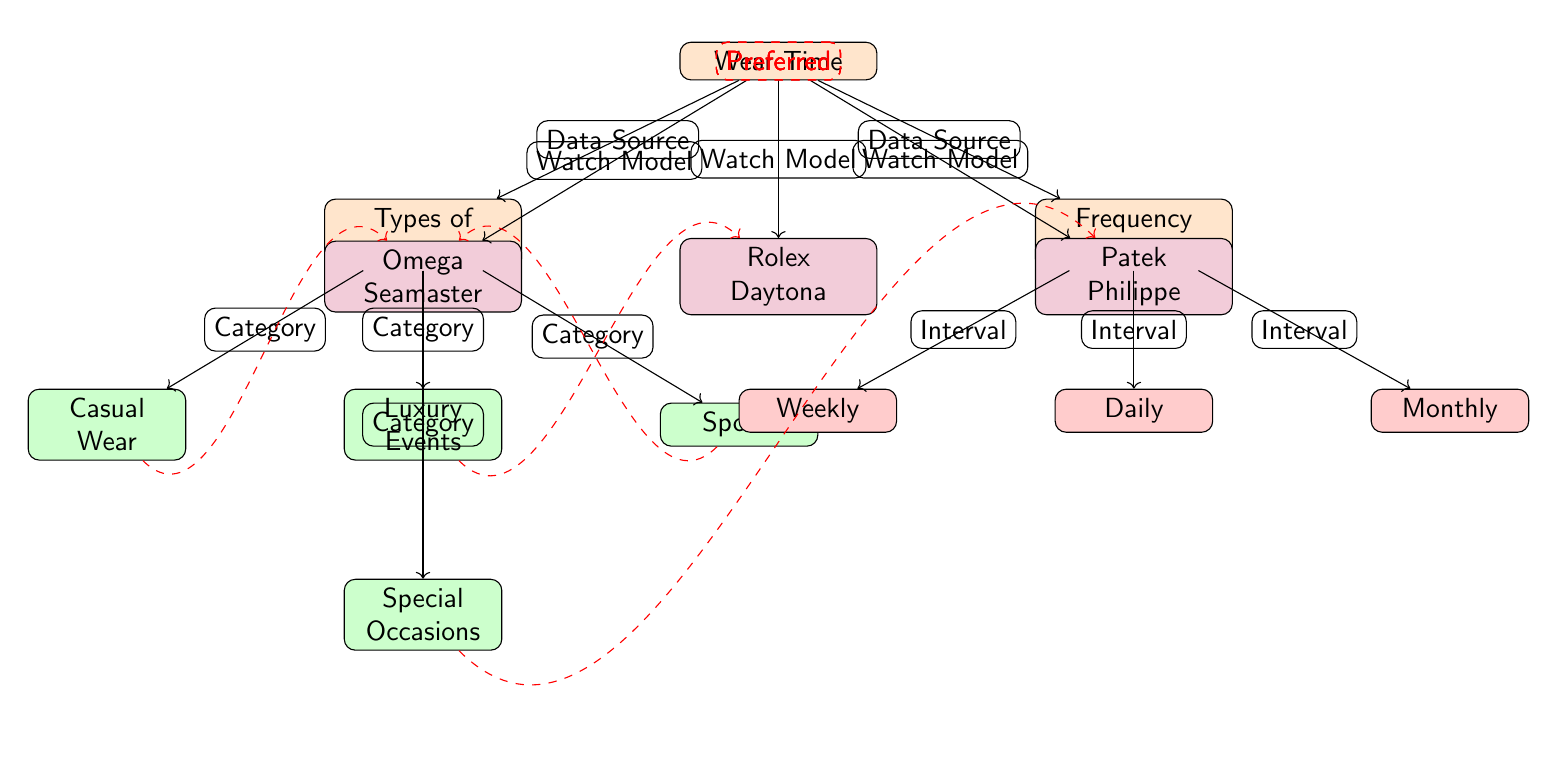What node represents types of activities? The diagram indicates "Types of Activities" as a main node positioned below the "Wear Time" node, reflecting the activities associated with wearing the watches.
Answer: Types of Activities How many watch models are listed in the diagram? The diagram features three specific watch models connected to the "Wear Time" node: Rolex Daytona, Omega Seamaster, and Patek Philippe. Thus, the total is three.
Answer: 3 What type of activity is labeled as preferred for the Rolex Daytona? According to the dashed connection from the "Luxury Events" node to the "Rolex Daytona" node, this watch model is marked as preferred for luxury events.
Answer: Luxury Events Which watch is preferred for casual wear? The diagram shows a dashed line from the "Casual Wear" node to the "Omega Seamaster" node, indicating that the Omega Seamaster is the preferred watch for casual occasions.
Answer: Omega Seamaster What is the frequency of use that corresponds to the activity node "Sports"? The flow from the "Sports" activity node suggests that it connects to the "Frequency of Use" section, but does not specify a direct frequency; however, the Omega Seamaster is noted as preferred for this activity, typically suggesting a more casual, possibly daily occurrence. Hence, we can deduce that "Daily" is a possible frequency.
Answer: Daily What model is associated with special occasions? The diagram clearly illustrates that the "Patek Philippe" node is connected via a dashed line from the "Special Occasions" node, indicating this watch's association with special occasions.
Answer: Patek Philippe Which activity has the highest connection to luxury events? The connection from the "Luxury Events" node indicates a direct association with the "Rolex Daytona," suggesting this watch is most commonly linked to luxury activities.
Answer: Rolex Daytona How is “Frequency of Use” categorized in the diagram? The "Frequency of Use" node branches into three categories—Daily, Weekly, and Monthly—illustrating different intervals of watch usage frequency.
Answer: Daily, Weekly, Monthly 